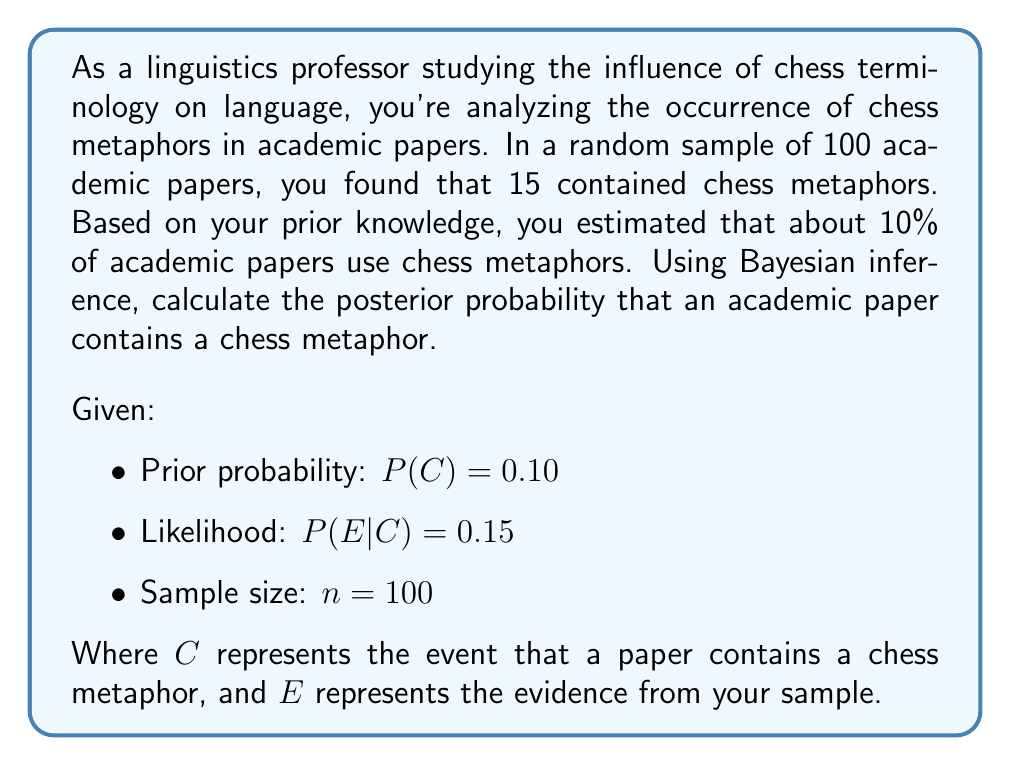Teach me how to tackle this problem. To solve this problem using Bayesian inference, we'll follow these steps:

1) First, we need to calculate $P(E)$, the probability of observing our evidence:

   $P(E) = P(E|C) \cdot P(C) + P(E|\neg C) \cdot P(\neg C)$

   Where $P(E|\neg C)$ is the probability of observing 15 papers with chess metaphors out of 100 if the true proportion is not 10%.

2) We can calculate $P(E|\neg C)$ using the binomial probability formula:

   $P(E|\neg C) = \binom{100}{15} \cdot (0.10)^{15} \cdot (0.90)^{85}$

3) Now we can calculate $P(E)$:

   $P(E) = 0.15 \cdot 0.10 + \binom{100}{15} \cdot (0.10)^{15} \cdot (0.90)^{85} \cdot 0.90$

4) Next, we apply Bayes' theorem:

   $P(C|E) = \frac{P(E|C) \cdot P(C)}{P(E)}$

5) Substituting our values:

   $P(C|E) = \frac{0.15 \cdot 0.10}{0.15 \cdot 0.10 + \binom{100}{15} \cdot (0.10)^{15} \cdot (0.90)^{85} \cdot 0.90}$

6) Calculating this gives us the posterior probability.
Answer: $P(C|E) \approx 0.1304$ or about 13.04% 